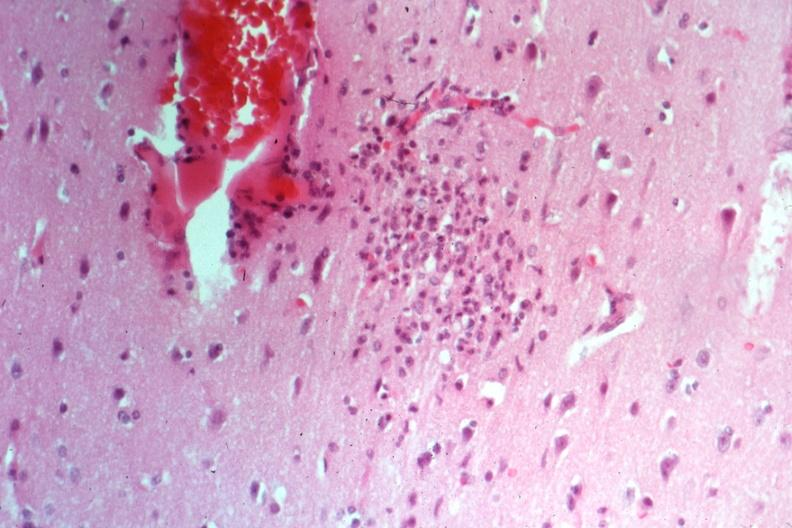s atrophy present?
Answer the question using a single word or phrase. No 